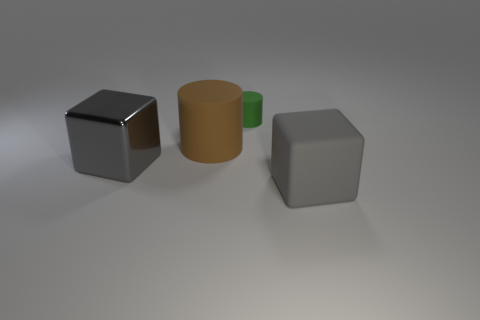Add 4 big purple matte things. How many objects exist? 8 Add 1 gray matte blocks. How many gray matte blocks exist? 2 Subtract 0 cyan balls. How many objects are left? 4 Subtract all tiny blue shiny objects. Subtract all large gray matte things. How many objects are left? 3 Add 3 large things. How many large things are left? 6 